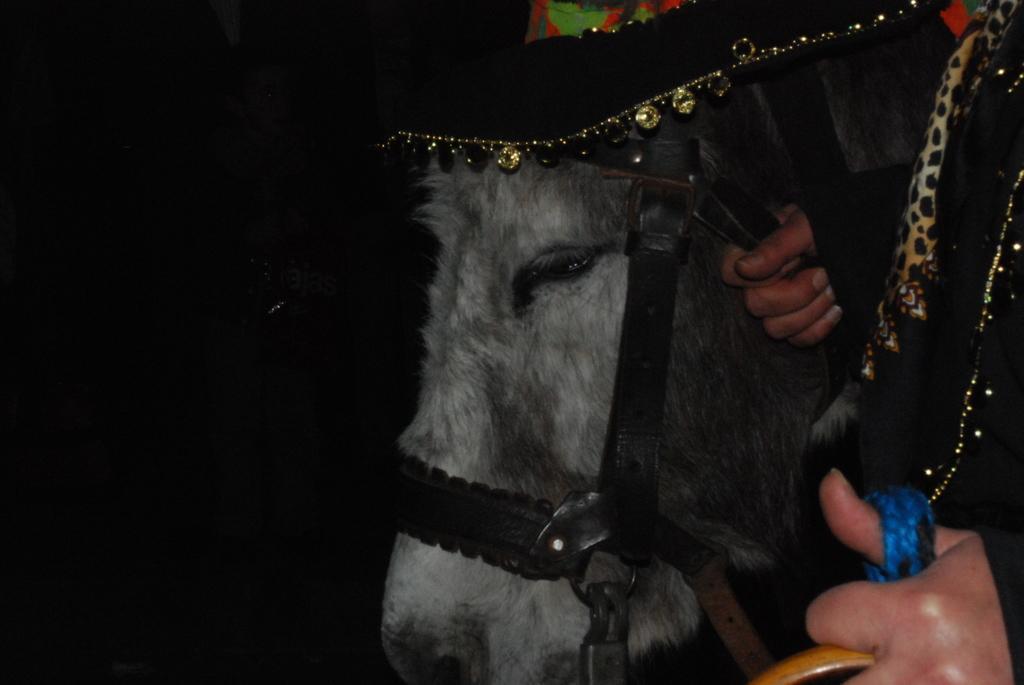In one or two sentences, can you explain what this image depicts? In front of the image there is a person holding the horse. Behind the horse there's another person standing. 